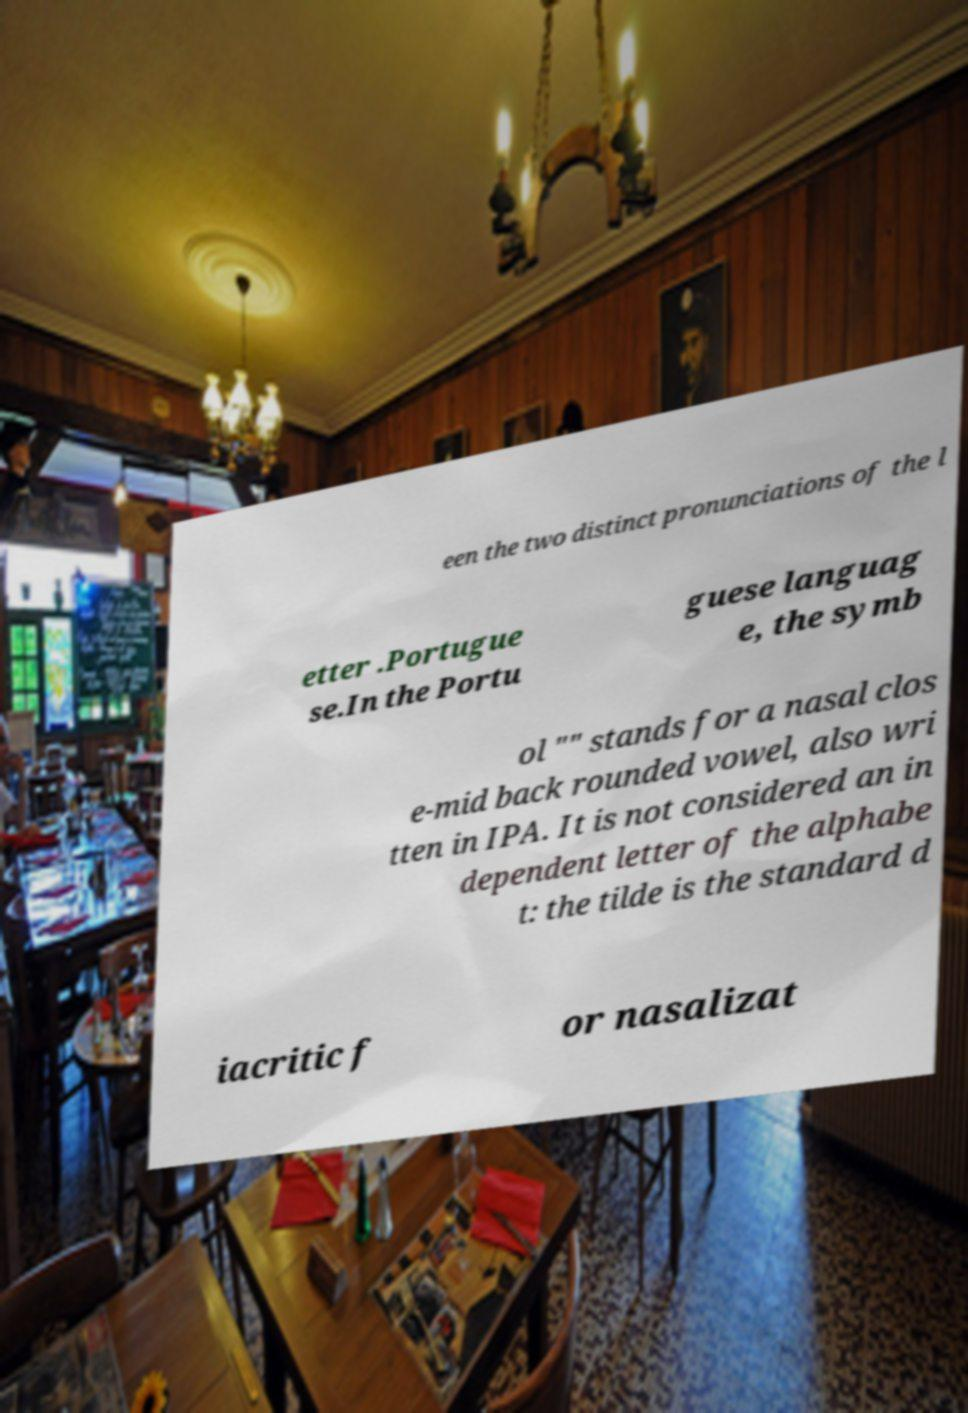Could you extract and type out the text from this image? een the two distinct pronunciations of the l etter .Portugue se.In the Portu guese languag e, the symb ol "" stands for a nasal clos e-mid back rounded vowel, also wri tten in IPA. It is not considered an in dependent letter of the alphabe t: the tilde is the standard d iacritic f or nasalizat 